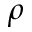<formula> <loc_0><loc_0><loc_500><loc_500>\rho</formula> 